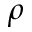<formula> <loc_0><loc_0><loc_500><loc_500>\rho</formula> 